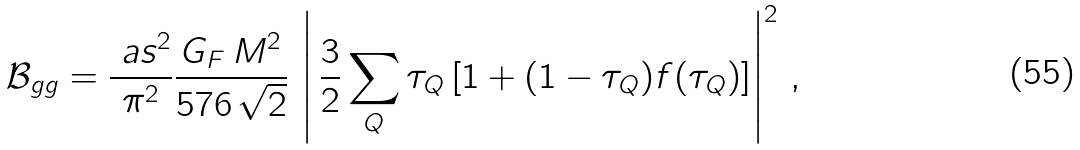Convert formula to latex. <formula><loc_0><loc_0><loc_500><loc_500>\mathcal { B } _ { g g } = \frac { \ a s ^ { 2 } } { \pi ^ { 2 } } \frac { G _ { F } \, M ^ { 2 } } { 5 7 6 \, \sqrt { 2 } } \, \left | \, \frac { 3 } { 2 } \sum _ { Q } \tau _ { Q } \left [ 1 + ( 1 - \tau _ { Q } ) f ( \tau _ { Q } ) \right ] \right | ^ { 2 } \, ,</formula> 